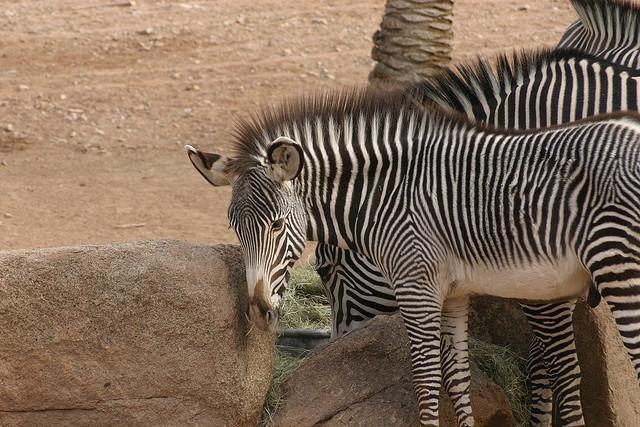How many zebras can you see?
Give a very brief answer. 3. 